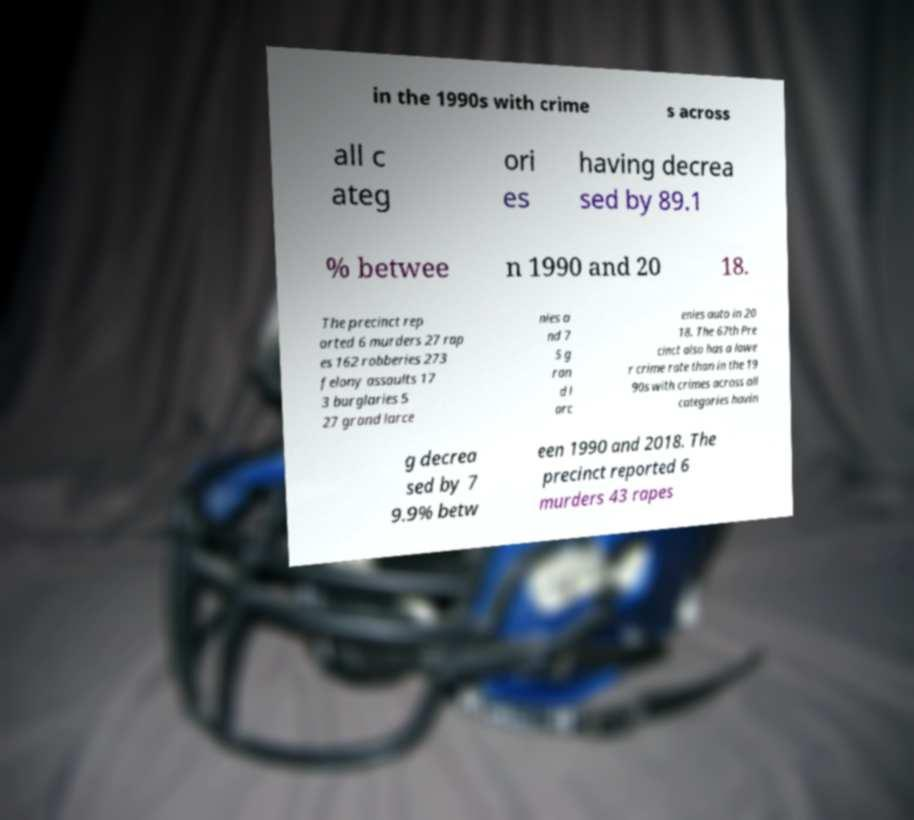Can you read and provide the text displayed in the image?This photo seems to have some interesting text. Can you extract and type it out for me? in the 1990s with crime s across all c ateg ori es having decrea sed by 89.1 % betwee n 1990 and 20 18. The precinct rep orted 6 murders 27 rap es 162 robberies 273 felony assaults 17 3 burglaries 5 27 grand larce nies a nd 7 5 g ran d l arc enies auto in 20 18. The 67th Pre cinct also has a lowe r crime rate than in the 19 90s with crimes across all categories havin g decrea sed by 7 9.9% betw een 1990 and 2018. The precinct reported 6 murders 43 rapes 